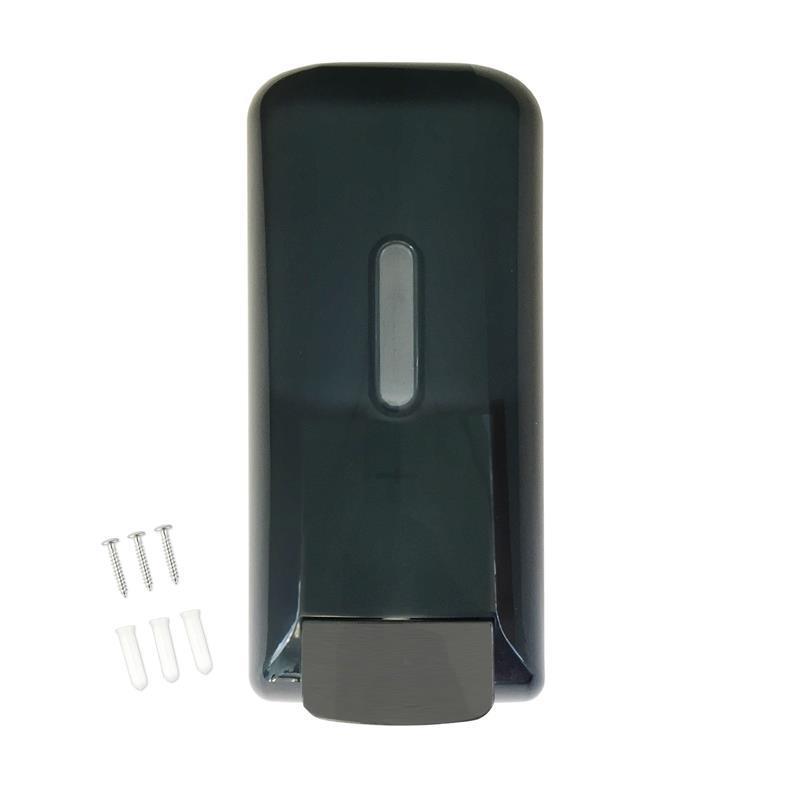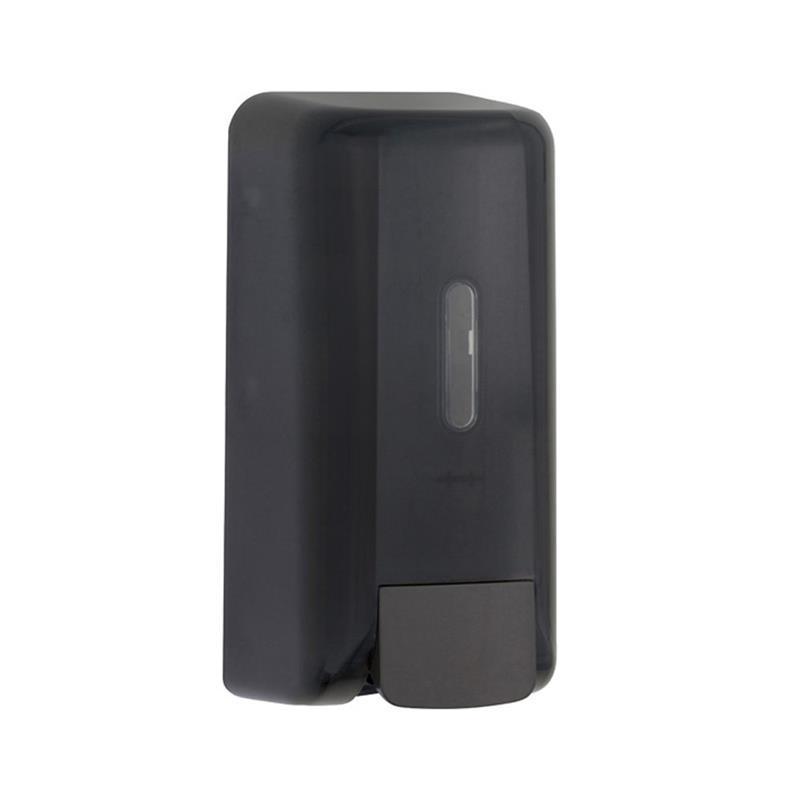The first image is the image on the left, the second image is the image on the right. Assess this claim about the two images: "All of the soap dispensers are primarily white.". Correct or not? Answer yes or no. No. The first image is the image on the left, the second image is the image on the right. Given the left and right images, does the statement "At least one of the soap dispensers is not white." hold true? Answer yes or no. Yes. 